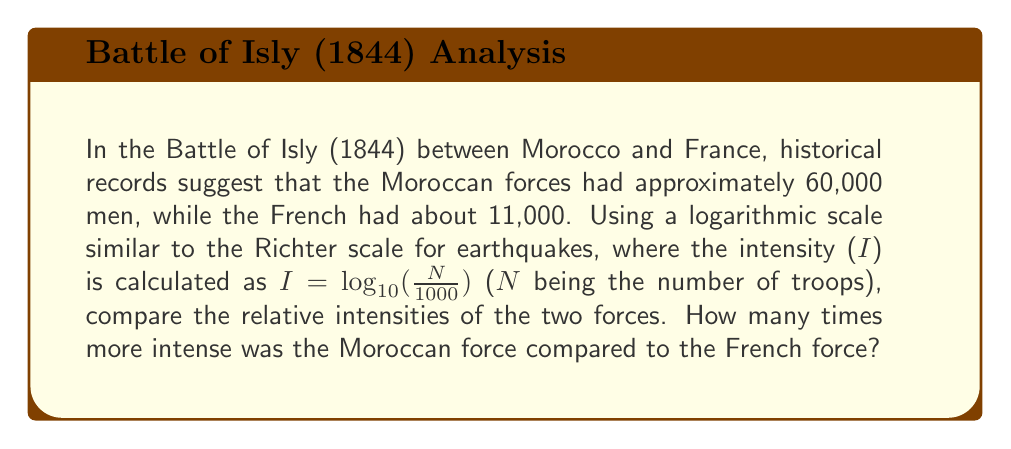Could you help me with this problem? Let's approach this step-by-step:

1) First, calculate the intensity for the Moroccan forces:
   $I_{Morocco} = \log_{10}(\frac{60000}{1000})$
   $= \log_{10}(60)$
   $\approx 1.7782$

2) Now, calculate the intensity for the French forces:
   $I_{France} = \log_{10}(\frac{11000}{1000})$
   $= \log_{10}(11)$
   $\approx 1.0414$

3) To compare the intensities, we need to convert back from the logarithmic scale. The difference in intensity is:
   $\Delta I = I_{Morocco} - I_{France} \approx 1.7782 - 1.0414 = 0.7368$

4) To find how many times more intense the Moroccan force was, we use:
   $10^{\Delta I} = 10^{0.7368} \approx 5.4544$

Therefore, the Moroccan force was approximately 5.45 times more intense than the French force on this logarithmic scale.
Answer: 5.45 times 